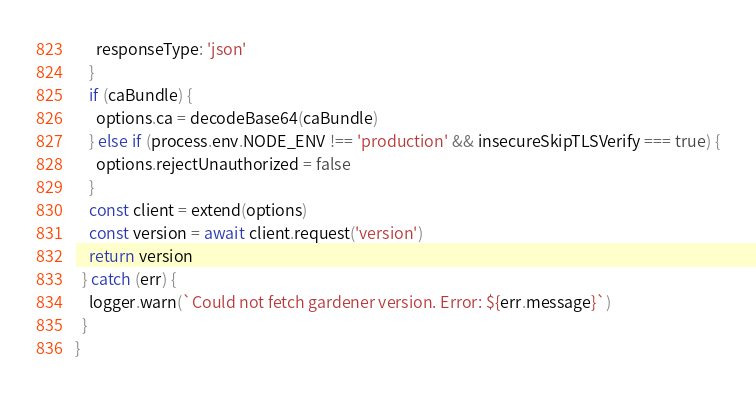Convert code to text. <code><loc_0><loc_0><loc_500><loc_500><_JavaScript_>      responseType: 'json'
    }
    if (caBundle) {
      options.ca = decodeBase64(caBundle)
    } else if (process.env.NODE_ENV !== 'production' && insecureSkipTLSVerify === true) {
      options.rejectUnauthorized = false
    }
    const client = extend(options)
    const version = await client.request('version')
    return version
  } catch (err) {
    logger.warn(`Could not fetch gardener version. Error: ${err.message}`)
  }
}
</code> 